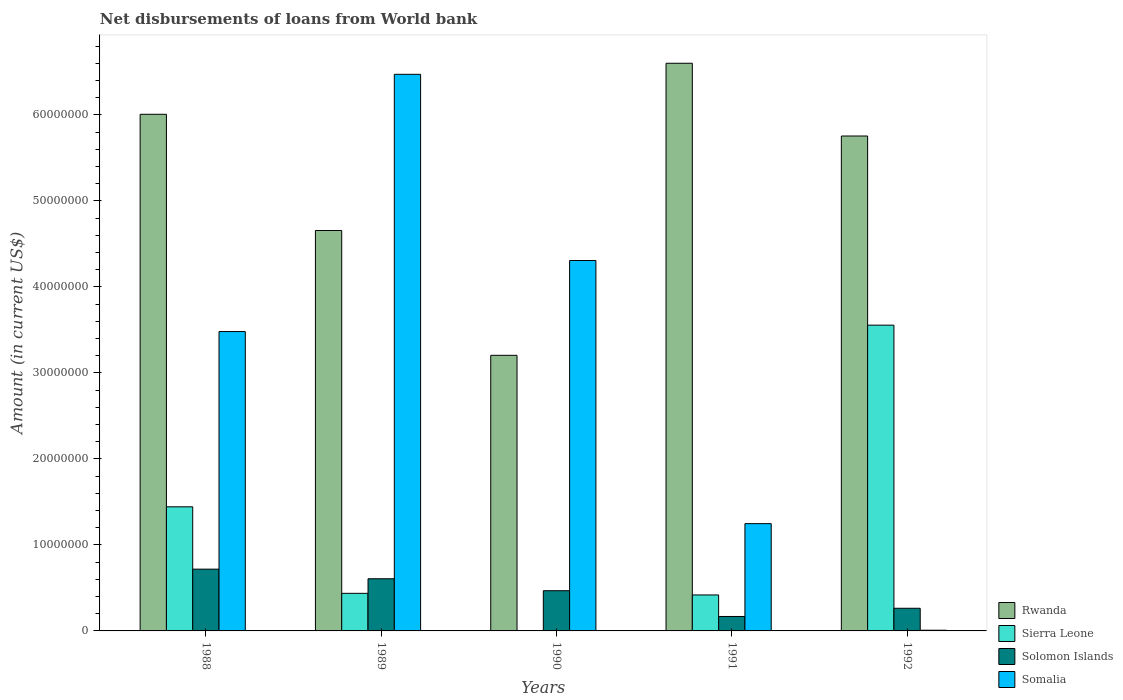How many different coloured bars are there?
Provide a short and direct response. 4. How many groups of bars are there?
Provide a succinct answer. 5. Are the number of bars per tick equal to the number of legend labels?
Make the answer very short. No. What is the amount of loan disbursed from World Bank in Solomon Islands in 1992?
Your response must be concise. 2.63e+06. Across all years, what is the maximum amount of loan disbursed from World Bank in Somalia?
Provide a short and direct response. 6.47e+07. Across all years, what is the minimum amount of loan disbursed from World Bank in Rwanda?
Your response must be concise. 3.20e+07. In which year was the amount of loan disbursed from World Bank in Solomon Islands maximum?
Offer a very short reply. 1988. What is the total amount of loan disbursed from World Bank in Sierra Leone in the graph?
Make the answer very short. 5.85e+07. What is the difference between the amount of loan disbursed from World Bank in Solomon Islands in 1989 and that in 1990?
Ensure brevity in your answer.  1.39e+06. What is the difference between the amount of loan disbursed from World Bank in Solomon Islands in 1988 and the amount of loan disbursed from World Bank in Rwanda in 1990?
Provide a succinct answer. -2.49e+07. What is the average amount of loan disbursed from World Bank in Sierra Leone per year?
Offer a very short reply. 1.17e+07. In the year 1991, what is the difference between the amount of loan disbursed from World Bank in Rwanda and amount of loan disbursed from World Bank in Solomon Islands?
Offer a very short reply. 6.43e+07. In how many years, is the amount of loan disbursed from World Bank in Sierra Leone greater than 12000000 US$?
Offer a terse response. 2. What is the ratio of the amount of loan disbursed from World Bank in Sierra Leone in 1988 to that in 1991?
Your answer should be very brief. 3.45. Is the difference between the amount of loan disbursed from World Bank in Rwanda in 1989 and 1990 greater than the difference between the amount of loan disbursed from World Bank in Solomon Islands in 1989 and 1990?
Your answer should be compact. Yes. What is the difference between the highest and the second highest amount of loan disbursed from World Bank in Rwanda?
Provide a succinct answer. 5.93e+06. What is the difference between the highest and the lowest amount of loan disbursed from World Bank in Sierra Leone?
Provide a succinct answer. 3.56e+07. Is it the case that in every year, the sum of the amount of loan disbursed from World Bank in Solomon Islands and amount of loan disbursed from World Bank in Sierra Leone is greater than the amount of loan disbursed from World Bank in Somalia?
Provide a succinct answer. No. How many bars are there?
Provide a short and direct response. 19. Are the values on the major ticks of Y-axis written in scientific E-notation?
Make the answer very short. No. Where does the legend appear in the graph?
Offer a very short reply. Bottom right. How are the legend labels stacked?
Provide a short and direct response. Vertical. What is the title of the graph?
Ensure brevity in your answer.  Net disbursements of loans from World bank. Does "Least developed countries" appear as one of the legend labels in the graph?
Provide a succinct answer. No. What is the Amount (in current US$) of Rwanda in 1988?
Provide a short and direct response. 6.01e+07. What is the Amount (in current US$) in Sierra Leone in 1988?
Your response must be concise. 1.44e+07. What is the Amount (in current US$) in Solomon Islands in 1988?
Your answer should be compact. 7.18e+06. What is the Amount (in current US$) of Somalia in 1988?
Give a very brief answer. 3.48e+07. What is the Amount (in current US$) in Rwanda in 1989?
Your answer should be compact. 4.66e+07. What is the Amount (in current US$) of Sierra Leone in 1989?
Your answer should be compact. 4.37e+06. What is the Amount (in current US$) of Solomon Islands in 1989?
Your answer should be very brief. 6.07e+06. What is the Amount (in current US$) of Somalia in 1989?
Offer a terse response. 6.47e+07. What is the Amount (in current US$) of Rwanda in 1990?
Give a very brief answer. 3.20e+07. What is the Amount (in current US$) in Solomon Islands in 1990?
Offer a terse response. 4.68e+06. What is the Amount (in current US$) of Somalia in 1990?
Your answer should be very brief. 4.31e+07. What is the Amount (in current US$) of Rwanda in 1991?
Your answer should be very brief. 6.60e+07. What is the Amount (in current US$) of Sierra Leone in 1991?
Make the answer very short. 4.18e+06. What is the Amount (in current US$) of Solomon Islands in 1991?
Offer a terse response. 1.68e+06. What is the Amount (in current US$) of Somalia in 1991?
Provide a succinct answer. 1.25e+07. What is the Amount (in current US$) of Rwanda in 1992?
Your response must be concise. 5.76e+07. What is the Amount (in current US$) of Sierra Leone in 1992?
Your response must be concise. 3.56e+07. What is the Amount (in current US$) of Solomon Islands in 1992?
Make the answer very short. 2.63e+06. What is the Amount (in current US$) of Somalia in 1992?
Provide a succinct answer. 8.10e+04. Across all years, what is the maximum Amount (in current US$) in Rwanda?
Give a very brief answer. 6.60e+07. Across all years, what is the maximum Amount (in current US$) in Sierra Leone?
Your response must be concise. 3.56e+07. Across all years, what is the maximum Amount (in current US$) in Solomon Islands?
Offer a very short reply. 7.18e+06. Across all years, what is the maximum Amount (in current US$) in Somalia?
Provide a succinct answer. 6.47e+07. Across all years, what is the minimum Amount (in current US$) in Rwanda?
Provide a short and direct response. 3.20e+07. Across all years, what is the minimum Amount (in current US$) in Sierra Leone?
Offer a terse response. 0. Across all years, what is the minimum Amount (in current US$) of Solomon Islands?
Your answer should be very brief. 1.68e+06. Across all years, what is the minimum Amount (in current US$) in Somalia?
Provide a succinct answer. 8.10e+04. What is the total Amount (in current US$) in Rwanda in the graph?
Make the answer very short. 2.62e+08. What is the total Amount (in current US$) of Sierra Leone in the graph?
Provide a short and direct response. 5.85e+07. What is the total Amount (in current US$) in Solomon Islands in the graph?
Ensure brevity in your answer.  2.22e+07. What is the total Amount (in current US$) in Somalia in the graph?
Your answer should be very brief. 1.55e+08. What is the difference between the Amount (in current US$) in Rwanda in 1988 and that in 1989?
Keep it short and to the point. 1.35e+07. What is the difference between the Amount (in current US$) in Sierra Leone in 1988 and that in 1989?
Your response must be concise. 1.01e+07. What is the difference between the Amount (in current US$) in Solomon Islands in 1988 and that in 1989?
Provide a succinct answer. 1.12e+06. What is the difference between the Amount (in current US$) of Somalia in 1988 and that in 1989?
Provide a short and direct response. -2.99e+07. What is the difference between the Amount (in current US$) of Rwanda in 1988 and that in 1990?
Your answer should be very brief. 2.80e+07. What is the difference between the Amount (in current US$) of Solomon Islands in 1988 and that in 1990?
Provide a succinct answer. 2.51e+06. What is the difference between the Amount (in current US$) of Somalia in 1988 and that in 1990?
Provide a succinct answer. -8.26e+06. What is the difference between the Amount (in current US$) in Rwanda in 1988 and that in 1991?
Your answer should be compact. -5.93e+06. What is the difference between the Amount (in current US$) in Sierra Leone in 1988 and that in 1991?
Your answer should be compact. 1.02e+07. What is the difference between the Amount (in current US$) of Solomon Islands in 1988 and that in 1991?
Your response must be concise. 5.50e+06. What is the difference between the Amount (in current US$) in Somalia in 1988 and that in 1991?
Provide a short and direct response. 2.23e+07. What is the difference between the Amount (in current US$) of Rwanda in 1988 and that in 1992?
Provide a short and direct response. 2.53e+06. What is the difference between the Amount (in current US$) of Sierra Leone in 1988 and that in 1992?
Give a very brief answer. -2.11e+07. What is the difference between the Amount (in current US$) in Solomon Islands in 1988 and that in 1992?
Offer a terse response. 4.55e+06. What is the difference between the Amount (in current US$) in Somalia in 1988 and that in 1992?
Provide a short and direct response. 3.47e+07. What is the difference between the Amount (in current US$) of Rwanda in 1989 and that in 1990?
Provide a succinct answer. 1.45e+07. What is the difference between the Amount (in current US$) of Solomon Islands in 1989 and that in 1990?
Give a very brief answer. 1.39e+06. What is the difference between the Amount (in current US$) of Somalia in 1989 and that in 1990?
Ensure brevity in your answer.  2.17e+07. What is the difference between the Amount (in current US$) of Rwanda in 1989 and that in 1991?
Offer a very short reply. -1.94e+07. What is the difference between the Amount (in current US$) of Sierra Leone in 1989 and that in 1991?
Your answer should be compact. 1.87e+05. What is the difference between the Amount (in current US$) in Solomon Islands in 1989 and that in 1991?
Your answer should be very brief. 4.39e+06. What is the difference between the Amount (in current US$) in Somalia in 1989 and that in 1991?
Offer a terse response. 5.23e+07. What is the difference between the Amount (in current US$) of Rwanda in 1989 and that in 1992?
Keep it short and to the point. -1.10e+07. What is the difference between the Amount (in current US$) in Sierra Leone in 1989 and that in 1992?
Offer a terse response. -3.12e+07. What is the difference between the Amount (in current US$) in Solomon Islands in 1989 and that in 1992?
Ensure brevity in your answer.  3.43e+06. What is the difference between the Amount (in current US$) of Somalia in 1989 and that in 1992?
Keep it short and to the point. 6.46e+07. What is the difference between the Amount (in current US$) in Rwanda in 1990 and that in 1991?
Offer a very short reply. -3.40e+07. What is the difference between the Amount (in current US$) of Solomon Islands in 1990 and that in 1991?
Offer a terse response. 3.00e+06. What is the difference between the Amount (in current US$) of Somalia in 1990 and that in 1991?
Provide a short and direct response. 3.06e+07. What is the difference between the Amount (in current US$) of Rwanda in 1990 and that in 1992?
Ensure brevity in your answer.  -2.55e+07. What is the difference between the Amount (in current US$) in Solomon Islands in 1990 and that in 1992?
Keep it short and to the point. 2.04e+06. What is the difference between the Amount (in current US$) of Somalia in 1990 and that in 1992?
Keep it short and to the point. 4.30e+07. What is the difference between the Amount (in current US$) of Rwanda in 1991 and that in 1992?
Ensure brevity in your answer.  8.46e+06. What is the difference between the Amount (in current US$) of Sierra Leone in 1991 and that in 1992?
Your answer should be very brief. -3.14e+07. What is the difference between the Amount (in current US$) in Solomon Islands in 1991 and that in 1992?
Make the answer very short. -9.54e+05. What is the difference between the Amount (in current US$) in Somalia in 1991 and that in 1992?
Your answer should be compact. 1.24e+07. What is the difference between the Amount (in current US$) in Rwanda in 1988 and the Amount (in current US$) in Sierra Leone in 1989?
Make the answer very short. 5.57e+07. What is the difference between the Amount (in current US$) in Rwanda in 1988 and the Amount (in current US$) in Solomon Islands in 1989?
Your answer should be very brief. 5.40e+07. What is the difference between the Amount (in current US$) in Rwanda in 1988 and the Amount (in current US$) in Somalia in 1989?
Give a very brief answer. -4.65e+06. What is the difference between the Amount (in current US$) of Sierra Leone in 1988 and the Amount (in current US$) of Solomon Islands in 1989?
Offer a very short reply. 8.37e+06. What is the difference between the Amount (in current US$) in Sierra Leone in 1988 and the Amount (in current US$) in Somalia in 1989?
Your response must be concise. -5.03e+07. What is the difference between the Amount (in current US$) in Solomon Islands in 1988 and the Amount (in current US$) in Somalia in 1989?
Provide a succinct answer. -5.75e+07. What is the difference between the Amount (in current US$) in Rwanda in 1988 and the Amount (in current US$) in Solomon Islands in 1990?
Provide a short and direct response. 5.54e+07. What is the difference between the Amount (in current US$) in Rwanda in 1988 and the Amount (in current US$) in Somalia in 1990?
Provide a short and direct response. 1.70e+07. What is the difference between the Amount (in current US$) of Sierra Leone in 1988 and the Amount (in current US$) of Solomon Islands in 1990?
Make the answer very short. 9.76e+06. What is the difference between the Amount (in current US$) in Sierra Leone in 1988 and the Amount (in current US$) in Somalia in 1990?
Keep it short and to the point. -2.86e+07. What is the difference between the Amount (in current US$) in Solomon Islands in 1988 and the Amount (in current US$) in Somalia in 1990?
Give a very brief answer. -3.59e+07. What is the difference between the Amount (in current US$) in Rwanda in 1988 and the Amount (in current US$) in Sierra Leone in 1991?
Ensure brevity in your answer.  5.59e+07. What is the difference between the Amount (in current US$) of Rwanda in 1988 and the Amount (in current US$) of Solomon Islands in 1991?
Make the answer very short. 5.84e+07. What is the difference between the Amount (in current US$) of Rwanda in 1988 and the Amount (in current US$) of Somalia in 1991?
Offer a very short reply. 4.76e+07. What is the difference between the Amount (in current US$) of Sierra Leone in 1988 and the Amount (in current US$) of Solomon Islands in 1991?
Provide a short and direct response. 1.28e+07. What is the difference between the Amount (in current US$) of Sierra Leone in 1988 and the Amount (in current US$) of Somalia in 1991?
Make the answer very short. 1.96e+06. What is the difference between the Amount (in current US$) of Solomon Islands in 1988 and the Amount (in current US$) of Somalia in 1991?
Give a very brief answer. -5.29e+06. What is the difference between the Amount (in current US$) of Rwanda in 1988 and the Amount (in current US$) of Sierra Leone in 1992?
Give a very brief answer. 2.45e+07. What is the difference between the Amount (in current US$) of Rwanda in 1988 and the Amount (in current US$) of Solomon Islands in 1992?
Offer a terse response. 5.74e+07. What is the difference between the Amount (in current US$) of Rwanda in 1988 and the Amount (in current US$) of Somalia in 1992?
Offer a very short reply. 6.00e+07. What is the difference between the Amount (in current US$) of Sierra Leone in 1988 and the Amount (in current US$) of Solomon Islands in 1992?
Ensure brevity in your answer.  1.18e+07. What is the difference between the Amount (in current US$) of Sierra Leone in 1988 and the Amount (in current US$) of Somalia in 1992?
Make the answer very short. 1.44e+07. What is the difference between the Amount (in current US$) in Solomon Islands in 1988 and the Amount (in current US$) in Somalia in 1992?
Give a very brief answer. 7.10e+06. What is the difference between the Amount (in current US$) in Rwanda in 1989 and the Amount (in current US$) in Solomon Islands in 1990?
Offer a terse response. 4.19e+07. What is the difference between the Amount (in current US$) of Rwanda in 1989 and the Amount (in current US$) of Somalia in 1990?
Your response must be concise. 3.49e+06. What is the difference between the Amount (in current US$) in Sierra Leone in 1989 and the Amount (in current US$) in Solomon Islands in 1990?
Offer a terse response. -3.05e+05. What is the difference between the Amount (in current US$) in Sierra Leone in 1989 and the Amount (in current US$) in Somalia in 1990?
Provide a short and direct response. -3.87e+07. What is the difference between the Amount (in current US$) of Solomon Islands in 1989 and the Amount (in current US$) of Somalia in 1990?
Offer a terse response. -3.70e+07. What is the difference between the Amount (in current US$) in Rwanda in 1989 and the Amount (in current US$) in Sierra Leone in 1991?
Give a very brief answer. 4.24e+07. What is the difference between the Amount (in current US$) of Rwanda in 1989 and the Amount (in current US$) of Solomon Islands in 1991?
Keep it short and to the point. 4.49e+07. What is the difference between the Amount (in current US$) of Rwanda in 1989 and the Amount (in current US$) of Somalia in 1991?
Ensure brevity in your answer.  3.41e+07. What is the difference between the Amount (in current US$) of Sierra Leone in 1989 and the Amount (in current US$) of Solomon Islands in 1991?
Make the answer very short. 2.69e+06. What is the difference between the Amount (in current US$) in Sierra Leone in 1989 and the Amount (in current US$) in Somalia in 1991?
Offer a terse response. -8.10e+06. What is the difference between the Amount (in current US$) in Solomon Islands in 1989 and the Amount (in current US$) in Somalia in 1991?
Give a very brief answer. -6.41e+06. What is the difference between the Amount (in current US$) in Rwanda in 1989 and the Amount (in current US$) in Sierra Leone in 1992?
Your answer should be compact. 1.10e+07. What is the difference between the Amount (in current US$) of Rwanda in 1989 and the Amount (in current US$) of Solomon Islands in 1992?
Give a very brief answer. 4.39e+07. What is the difference between the Amount (in current US$) in Rwanda in 1989 and the Amount (in current US$) in Somalia in 1992?
Make the answer very short. 4.65e+07. What is the difference between the Amount (in current US$) in Sierra Leone in 1989 and the Amount (in current US$) in Solomon Islands in 1992?
Offer a very short reply. 1.74e+06. What is the difference between the Amount (in current US$) in Sierra Leone in 1989 and the Amount (in current US$) in Somalia in 1992?
Give a very brief answer. 4.29e+06. What is the difference between the Amount (in current US$) in Solomon Islands in 1989 and the Amount (in current US$) in Somalia in 1992?
Make the answer very short. 5.98e+06. What is the difference between the Amount (in current US$) in Rwanda in 1990 and the Amount (in current US$) in Sierra Leone in 1991?
Provide a short and direct response. 2.79e+07. What is the difference between the Amount (in current US$) in Rwanda in 1990 and the Amount (in current US$) in Solomon Islands in 1991?
Keep it short and to the point. 3.04e+07. What is the difference between the Amount (in current US$) of Rwanda in 1990 and the Amount (in current US$) of Somalia in 1991?
Give a very brief answer. 1.96e+07. What is the difference between the Amount (in current US$) in Solomon Islands in 1990 and the Amount (in current US$) in Somalia in 1991?
Provide a short and direct response. -7.80e+06. What is the difference between the Amount (in current US$) of Rwanda in 1990 and the Amount (in current US$) of Sierra Leone in 1992?
Your answer should be very brief. -3.51e+06. What is the difference between the Amount (in current US$) in Rwanda in 1990 and the Amount (in current US$) in Solomon Islands in 1992?
Ensure brevity in your answer.  2.94e+07. What is the difference between the Amount (in current US$) in Rwanda in 1990 and the Amount (in current US$) in Somalia in 1992?
Provide a short and direct response. 3.20e+07. What is the difference between the Amount (in current US$) of Solomon Islands in 1990 and the Amount (in current US$) of Somalia in 1992?
Provide a short and direct response. 4.60e+06. What is the difference between the Amount (in current US$) of Rwanda in 1991 and the Amount (in current US$) of Sierra Leone in 1992?
Provide a succinct answer. 3.05e+07. What is the difference between the Amount (in current US$) in Rwanda in 1991 and the Amount (in current US$) in Solomon Islands in 1992?
Give a very brief answer. 6.34e+07. What is the difference between the Amount (in current US$) of Rwanda in 1991 and the Amount (in current US$) of Somalia in 1992?
Your response must be concise. 6.59e+07. What is the difference between the Amount (in current US$) in Sierra Leone in 1991 and the Amount (in current US$) in Solomon Islands in 1992?
Make the answer very short. 1.55e+06. What is the difference between the Amount (in current US$) in Sierra Leone in 1991 and the Amount (in current US$) in Somalia in 1992?
Your answer should be compact. 4.10e+06. What is the difference between the Amount (in current US$) in Solomon Islands in 1991 and the Amount (in current US$) in Somalia in 1992?
Make the answer very short. 1.60e+06. What is the average Amount (in current US$) in Rwanda per year?
Your response must be concise. 5.25e+07. What is the average Amount (in current US$) in Sierra Leone per year?
Keep it short and to the point. 1.17e+07. What is the average Amount (in current US$) of Solomon Islands per year?
Your response must be concise. 4.45e+06. What is the average Amount (in current US$) of Somalia per year?
Offer a terse response. 3.10e+07. In the year 1988, what is the difference between the Amount (in current US$) in Rwanda and Amount (in current US$) in Sierra Leone?
Offer a very short reply. 4.56e+07. In the year 1988, what is the difference between the Amount (in current US$) in Rwanda and Amount (in current US$) in Solomon Islands?
Your answer should be very brief. 5.29e+07. In the year 1988, what is the difference between the Amount (in current US$) of Rwanda and Amount (in current US$) of Somalia?
Ensure brevity in your answer.  2.53e+07. In the year 1988, what is the difference between the Amount (in current US$) of Sierra Leone and Amount (in current US$) of Solomon Islands?
Your response must be concise. 7.25e+06. In the year 1988, what is the difference between the Amount (in current US$) of Sierra Leone and Amount (in current US$) of Somalia?
Ensure brevity in your answer.  -2.04e+07. In the year 1988, what is the difference between the Amount (in current US$) of Solomon Islands and Amount (in current US$) of Somalia?
Give a very brief answer. -2.76e+07. In the year 1989, what is the difference between the Amount (in current US$) in Rwanda and Amount (in current US$) in Sierra Leone?
Your answer should be compact. 4.22e+07. In the year 1989, what is the difference between the Amount (in current US$) of Rwanda and Amount (in current US$) of Solomon Islands?
Offer a terse response. 4.05e+07. In the year 1989, what is the difference between the Amount (in current US$) of Rwanda and Amount (in current US$) of Somalia?
Your answer should be compact. -1.82e+07. In the year 1989, what is the difference between the Amount (in current US$) in Sierra Leone and Amount (in current US$) in Solomon Islands?
Provide a succinct answer. -1.70e+06. In the year 1989, what is the difference between the Amount (in current US$) of Sierra Leone and Amount (in current US$) of Somalia?
Your response must be concise. -6.04e+07. In the year 1989, what is the difference between the Amount (in current US$) of Solomon Islands and Amount (in current US$) of Somalia?
Offer a terse response. -5.87e+07. In the year 1990, what is the difference between the Amount (in current US$) of Rwanda and Amount (in current US$) of Solomon Islands?
Provide a succinct answer. 2.74e+07. In the year 1990, what is the difference between the Amount (in current US$) of Rwanda and Amount (in current US$) of Somalia?
Make the answer very short. -1.10e+07. In the year 1990, what is the difference between the Amount (in current US$) in Solomon Islands and Amount (in current US$) in Somalia?
Give a very brief answer. -3.84e+07. In the year 1991, what is the difference between the Amount (in current US$) of Rwanda and Amount (in current US$) of Sierra Leone?
Offer a terse response. 6.18e+07. In the year 1991, what is the difference between the Amount (in current US$) of Rwanda and Amount (in current US$) of Solomon Islands?
Offer a very short reply. 6.43e+07. In the year 1991, what is the difference between the Amount (in current US$) of Rwanda and Amount (in current US$) of Somalia?
Make the answer very short. 5.35e+07. In the year 1991, what is the difference between the Amount (in current US$) in Sierra Leone and Amount (in current US$) in Solomon Islands?
Provide a short and direct response. 2.50e+06. In the year 1991, what is the difference between the Amount (in current US$) in Sierra Leone and Amount (in current US$) in Somalia?
Provide a succinct answer. -8.29e+06. In the year 1991, what is the difference between the Amount (in current US$) of Solomon Islands and Amount (in current US$) of Somalia?
Your answer should be very brief. -1.08e+07. In the year 1992, what is the difference between the Amount (in current US$) of Rwanda and Amount (in current US$) of Sierra Leone?
Ensure brevity in your answer.  2.20e+07. In the year 1992, what is the difference between the Amount (in current US$) in Rwanda and Amount (in current US$) in Solomon Islands?
Offer a very short reply. 5.49e+07. In the year 1992, what is the difference between the Amount (in current US$) in Rwanda and Amount (in current US$) in Somalia?
Offer a very short reply. 5.75e+07. In the year 1992, what is the difference between the Amount (in current US$) in Sierra Leone and Amount (in current US$) in Solomon Islands?
Ensure brevity in your answer.  3.29e+07. In the year 1992, what is the difference between the Amount (in current US$) of Sierra Leone and Amount (in current US$) of Somalia?
Provide a short and direct response. 3.55e+07. In the year 1992, what is the difference between the Amount (in current US$) in Solomon Islands and Amount (in current US$) in Somalia?
Your answer should be very brief. 2.55e+06. What is the ratio of the Amount (in current US$) of Rwanda in 1988 to that in 1989?
Your answer should be compact. 1.29. What is the ratio of the Amount (in current US$) of Sierra Leone in 1988 to that in 1989?
Your answer should be compact. 3.3. What is the ratio of the Amount (in current US$) in Solomon Islands in 1988 to that in 1989?
Keep it short and to the point. 1.18. What is the ratio of the Amount (in current US$) of Somalia in 1988 to that in 1989?
Ensure brevity in your answer.  0.54. What is the ratio of the Amount (in current US$) in Rwanda in 1988 to that in 1990?
Keep it short and to the point. 1.87. What is the ratio of the Amount (in current US$) of Solomon Islands in 1988 to that in 1990?
Give a very brief answer. 1.54. What is the ratio of the Amount (in current US$) in Somalia in 1988 to that in 1990?
Keep it short and to the point. 0.81. What is the ratio of the Amount (in current US$) in Rwanda in 1988 to that in 1991?
Offer a terse response. 0.91. What is the ratio of the Amount (in current US$) of Sierra Leone in 1988 to that in 1991?
Provide a succinct answer. 3.45. What is the ratio of the Amount (in current US$) in Solomon Islands in 1988 to that in 1991?
Give a very brief answer. 4.28. What is the ratio of the Amount (in current US$) in Somalia in 1988 to that in 1991?
Make the answer very short. 2.79. What is the ratio of the Amount (in current US$) of Rwanda in 1988 to that in 1992?
Your response must be concise. 1.04. What is the ratio of the Amount (in current US$) in Sierra Leone in 1988 to that in 1992?
Give a very brief answer. 0.41. What is the ratio of the Amount (in current US$) in Solomon Islands in 1988 to that in 1992?
Offer a terse response. 2.73. What is the ratio of the Amount (in current US$) in Somalia in 1988 to that in 1992?
Provide a short and direct response. 429.8. What is the ratio of the Amount (in current US$) of Rwanda in 1989 to that in 1990?
Provide a succinct answer. 1.45. What is the ratio of the Amount (in current US$) in Solomon Islands in 1989 to that in 1990?
Your response must be concise. 1.3. What is the ratio of the Amount (in current US$) in Somalia in 1989 to that in 1990?
Provide a succinct answer. 1.5. What is the ratio of the Amount (in current US$) in Rwanda in 1989 to that in 1991?
Provide a short and direct response. 0.71. What is the ratio of the Amount (in current US$) of Sierra Leone in 1989 to that in 1991?
Offer a very short reply. 1.04. What is the ratio of the Amount (in current US$) of Solomon Islands in 1989 to that in 1991?
Ensure brevity in your answer.  3.61. What is the ratio of the Amount (in current US$) of Somalia in 1989 to that in 1991?
Give a very brief answer. 5.19. What is the ratio of the Amount (in current US$) in Rwanda in 1989 to that in 1992?
Make the answer very short. 0.81. What is the ratio of the Amount (in current US$) of Sierra Leone in 1989 to that in 1992?
Your answer should be compact. 0.12. What is the ratio of the Amount (in current US$) of Solomon Islands in 1989 to that in 1992?
Offer a terse response. 2.3. What is the ratio of the Amount (in current US$) in Somalia in 1989 to that in 1992?
Make the answer very short. 799.12. What is the ratio of the Amount (in current US$) of Rwanda in 1990 to that in 1991?
Ensure brevity in your answer.  0.49. What is the ratio of the Amount (in current US$) in Solomon Islands in 1990 to that in 1991?
Provide a succinct answer. 2.79. What is the ratio of the Amount (in current US$) in Somalia in 1990 to that in 1991?
Your answer should be very brief. 3.45. What is the ratio of the Amount (in current US$) of Rwanda in 1990 to that in 1992?
Your answer should be very brief. 0.56. What is the ratio of the Amount (in current US$) in Solomon Islands in 1990 to that in 1992?
Offer a terse response. 1.78. What is the ratio of the Amount (in current US$) in Somalia in 1990 to that in 1992?
Ensure brevity in your answer.  531.81. What is the ratio of the Amount (in current US$) of Rwanda in 1991 to that in 1992?
Provide a succinct answer. 1.15. What is the ratio of the Amount (in current US$) of Sierra Leone in 1991 to that in 1992?
Your response must be concise. 0.12. What is the ratio of the Amount (in current US$) of Solomon Islands in 1991 to that in 1992?
Your answer should be compact. 0.64. What is the ratio of the Amount (in current US$) of Somalia in 1991 to that in 1992?
Make the answer very short. 154.01. What is the difference between the highest and the second highest Amount (in current US$) in Rwanda?
Offer a terse response. 5.93e+06. What is the difference between the highest and the second highest Amount (in current US$) in Sierra Leone?
Make the answer very short. 2.11e+07. What is the difference between the highest and the second highest Amount (in current US$) of Solomon Islands?
Give a very brief answer. 1.12e+06. What is the difference between the highest and the second highest Amount (in current US$) of Somalia?
Give a very brief answer. 2.17e+07. What is the difference between the highest and the lowest Amount (in current US$) of Rwanda?
Your answer should be compact. 3.40e+07. What is the difference between the highest and the lowest Amount (in current US$) in Sierra Leone?
Provide a short and direct response. 3.56e+07. What is the difference between the highest and the lowest Amount (in current US$) of Solomon Islands?
Make the answer very short. 5.50e+06. What is the difference between the highest and the lowest Amount (in current US$) in Somalia?
Provide a succinct answer. 6.46e+07. 